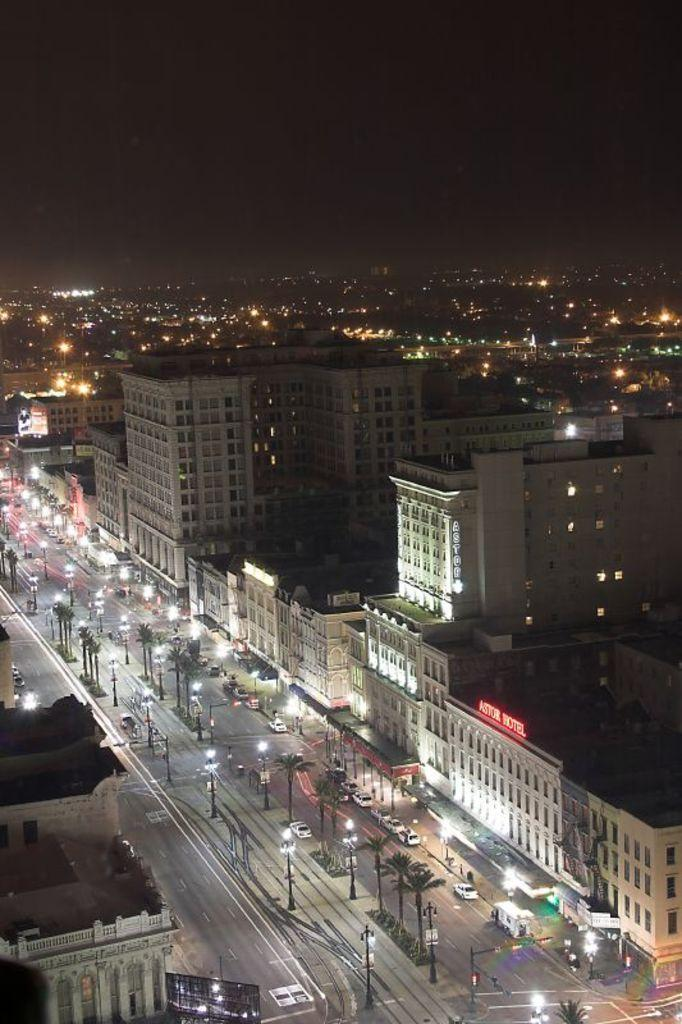What type of structures can be seen in the image? There are buildings in the image. What other natural elements are present in the image? There are trees in the image. What mode of transportation can be seen on the road in the image? There are vehicles on the road in the image. What type of whip is being used to control the trees in the image? There is no whip present in the image, and trees do not require control. 